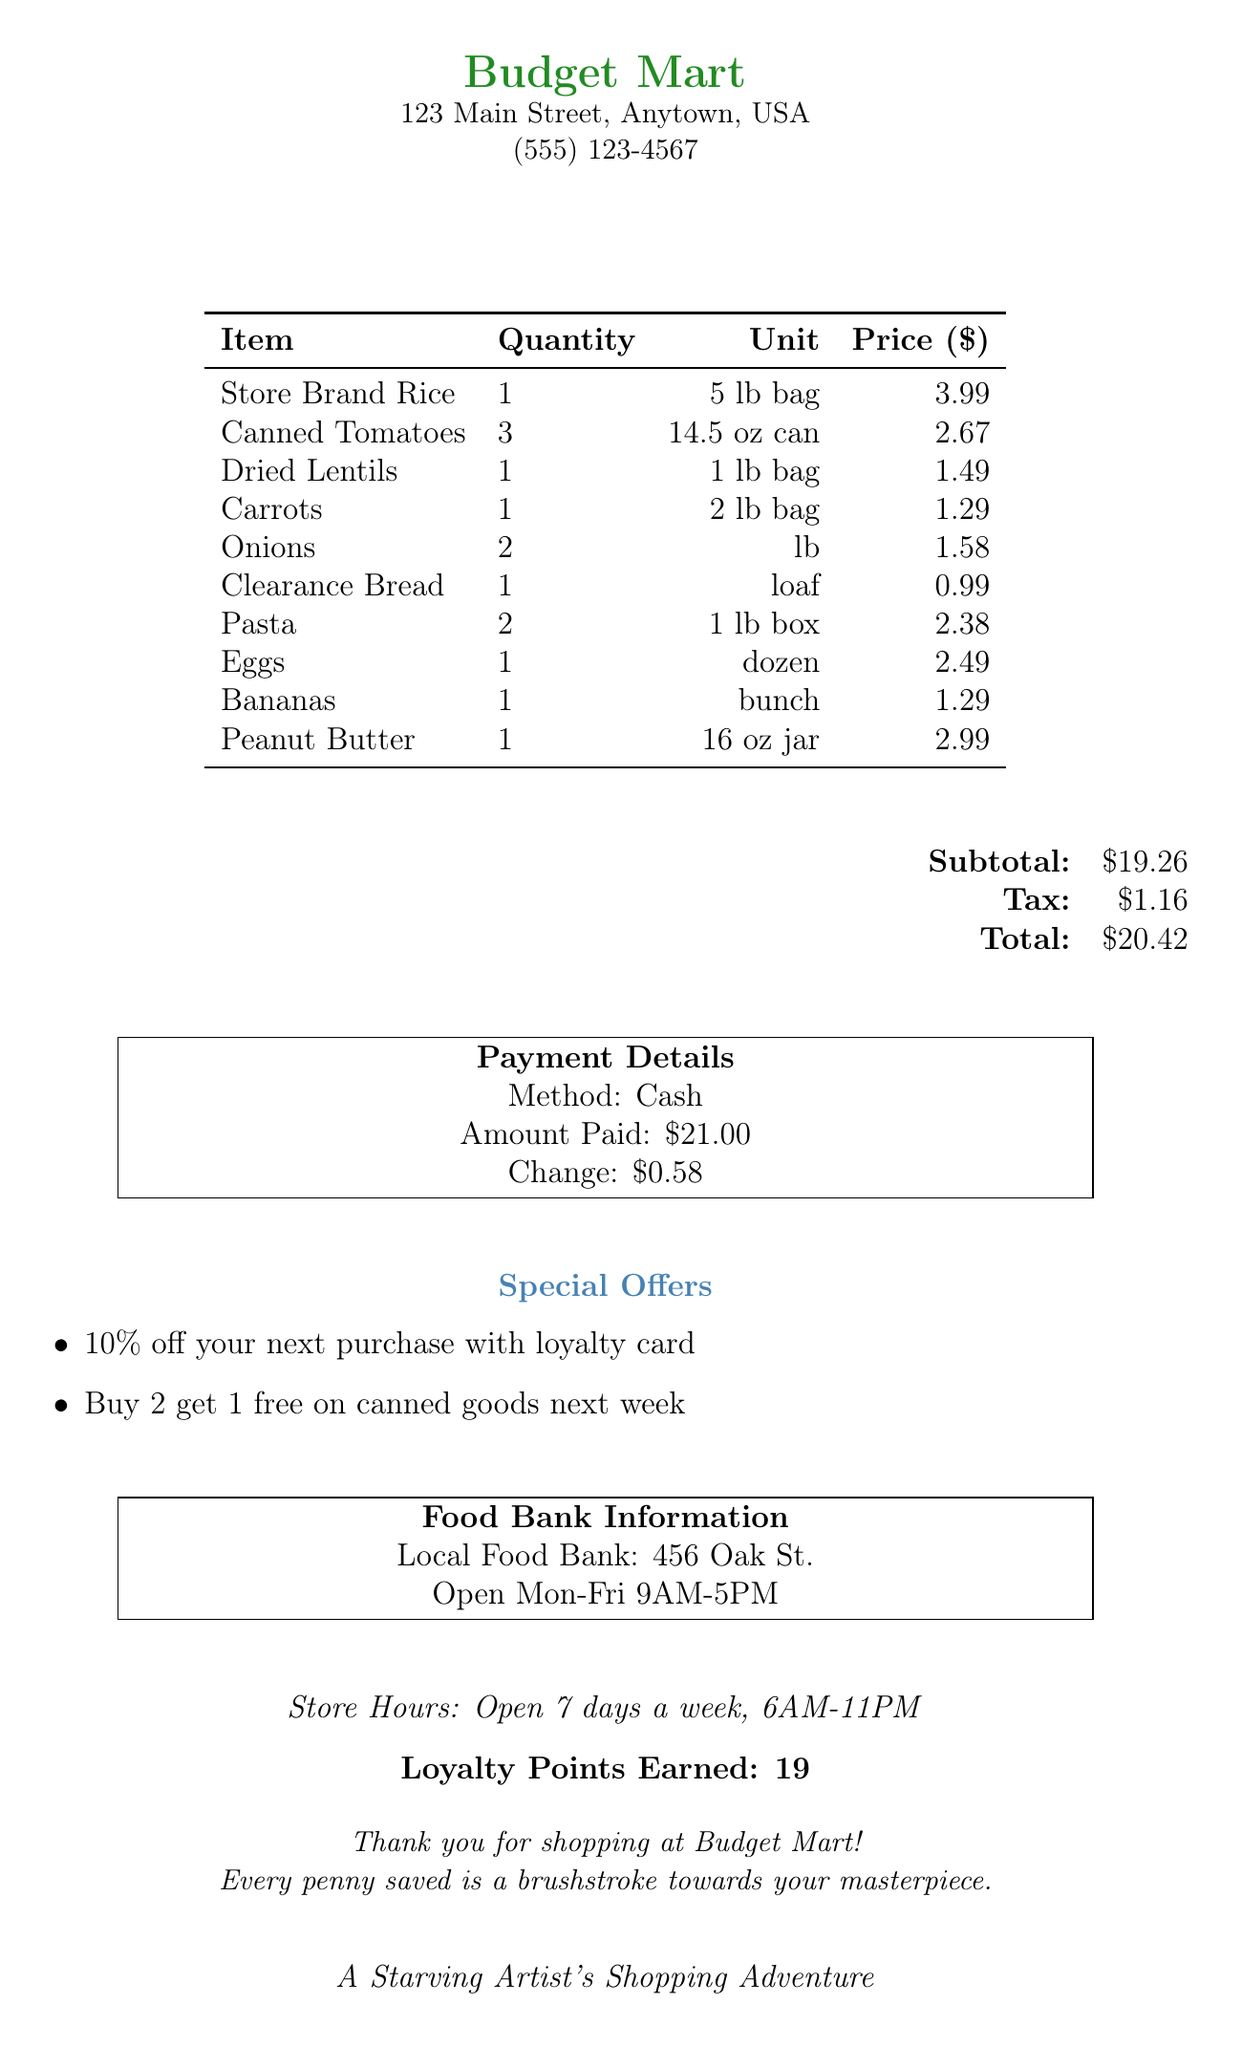what is the store name? The store name is explicitly stated at the top of the document.
Answer: Budget Mart what is the total amount spent? The total amount is listed in the payment details section of the document.
Answer: $20.42 who was the cashier? The cashier's name is provided in the date and time section of the document.
Answer: Sarah how many eggs were purchased? The number of eggs is indicated in the item list section of the document.
Answer: 1 dozen what special offer is available next week? The special offers section mentions a specific deal regarding canned goods for the following week.
Answer: Buy 2 get 1 free on canned goods next week what is the subtotal of the groceries? The subtotal is found in the financial summary of the document.
Answer: $19.26 where is the local food bank located? The food bank information section provides the address of the local food bank.
Answer: 456 Oak St how many loyalty points were earned? The loyalty points earned are clearly mentioned toward the end of the document.
Answer: 19 what type of payment was used? The payment method is stated in the payment details section of the document.
Answer: Cash 